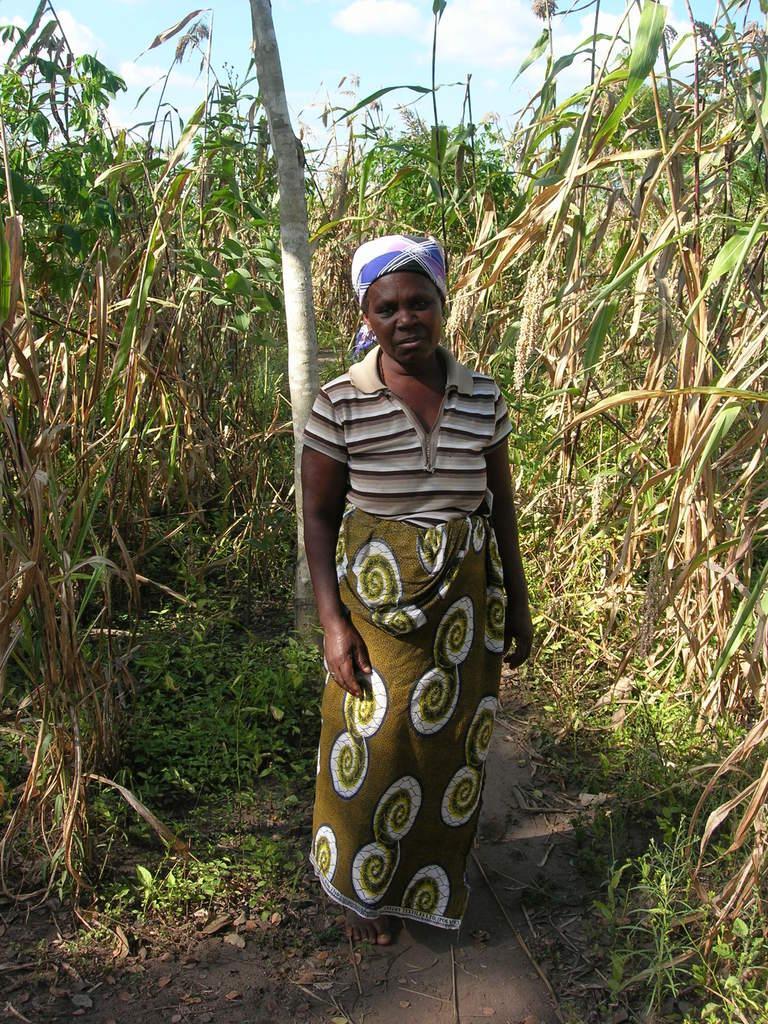Could you give a brief overview of what you see in this image? In this image I can see there is a person standing and there are plants behind the person. 